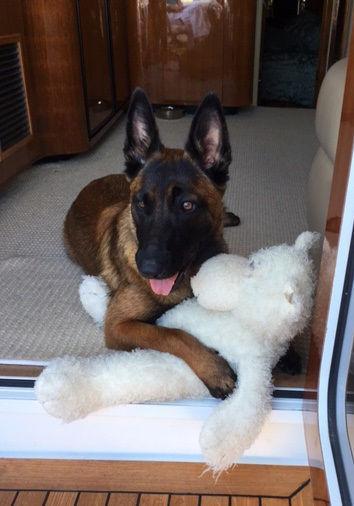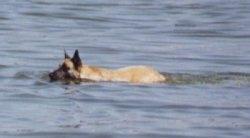The first image is the image on the left, the second image is the image on the right. For the images shown, is this caption "In one of the images there is a dog in the water in the center of the images." true? Answer yes or no. Yes. The first image is the image on the left, the second image is the image on the right. Considering the images on both sides, is "Two dogs are in water." valid? Answer yes or no. No. 